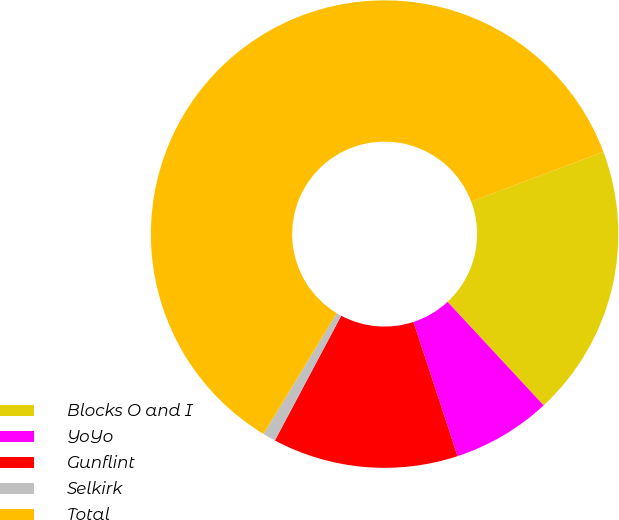Convert chart. <chart><loc_0><loc_0><loc_500><loc_500><pie_chart><fcel>Blocks O and I<fcel>YoYo<fcel>Gunflint<fcel>Selkirk<fcel>Total<nl><fcel>18.81%<fcel>6.86%<fcel>12.83%<fcel>0.89%<fcel>60.61%<nl></chart> 